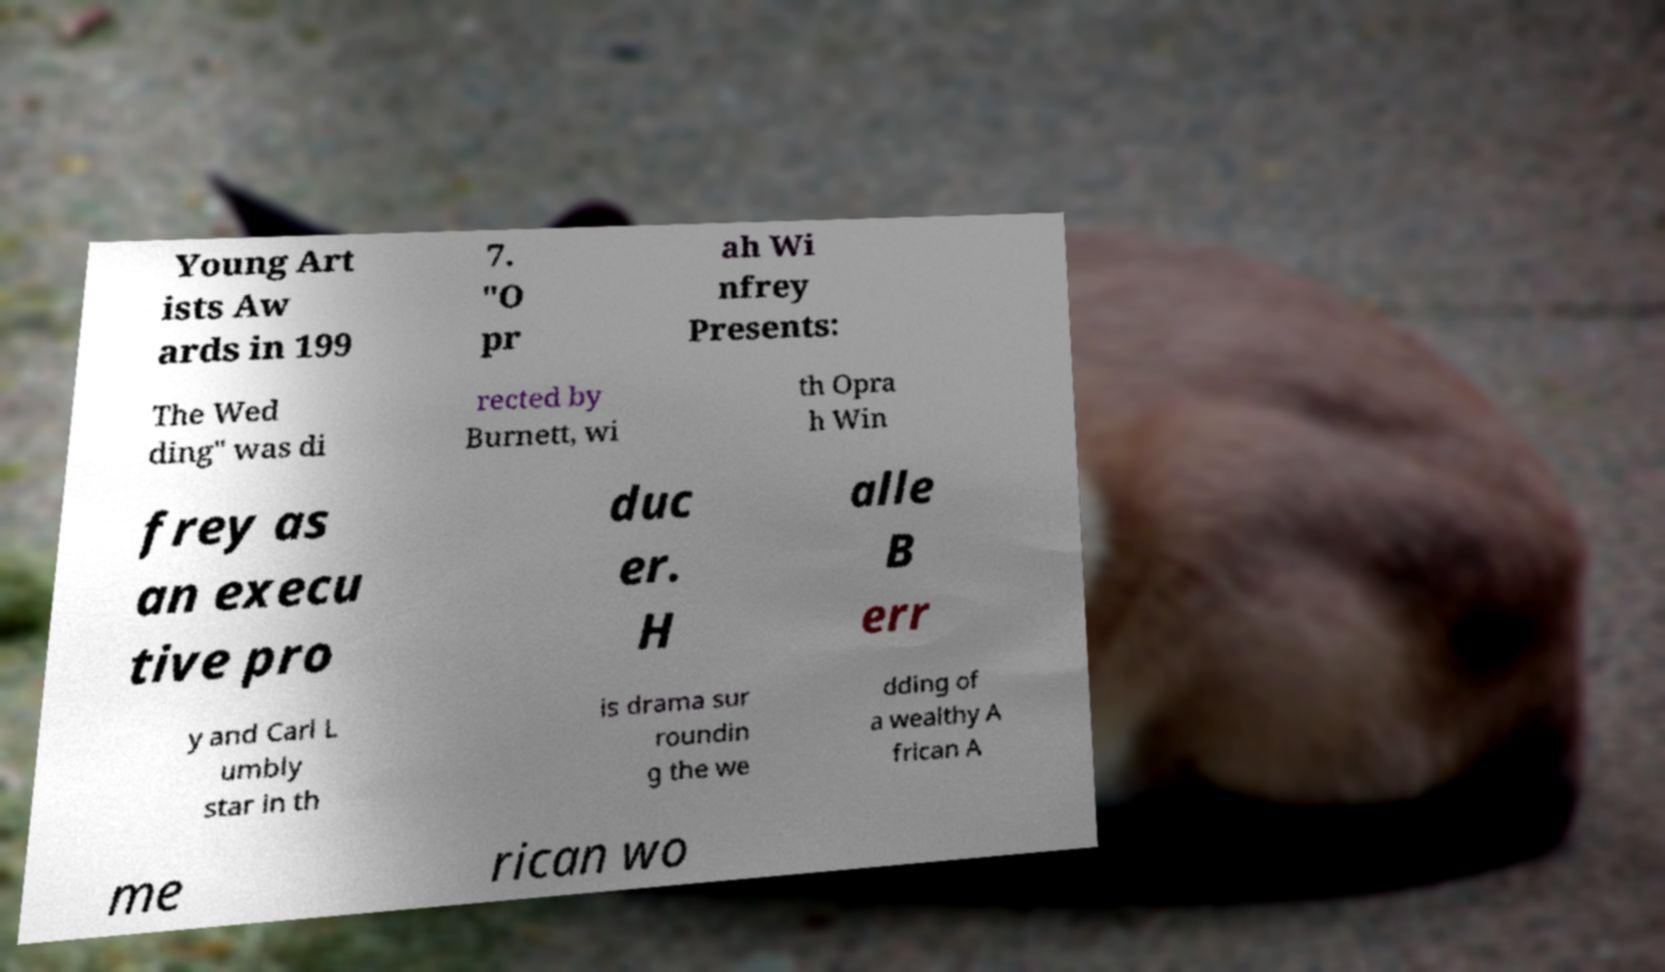There's text embedded in this image that I need extracted. Can you transcribe it verbatim? Young Art ists Aw ards in 199 7. "O pr ah Wi nfrey Presents: The Wed ding" was di rected by Burnett, wi th Opra h Win frey as an execu tive pro duc er. H alle B err y and Carl L umbly star in th is drama sur roundin g the we dding of a wealthy A frican A me rican wo 